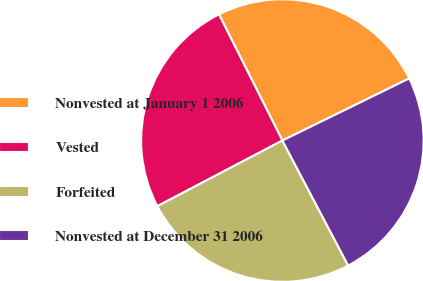Convert chart. <chart><loc_0><loc_0><loc_500><loc_500><pie_chart><fcel>Nonvested at January 1 2006<fcel>Vested<fcel>Forfeited<fcel>Nonvested at December 31 2006<nl><fcel>25.17%<fcel>25.28%<fcel>25.02%<fcel>24.54%<nl></chart> 